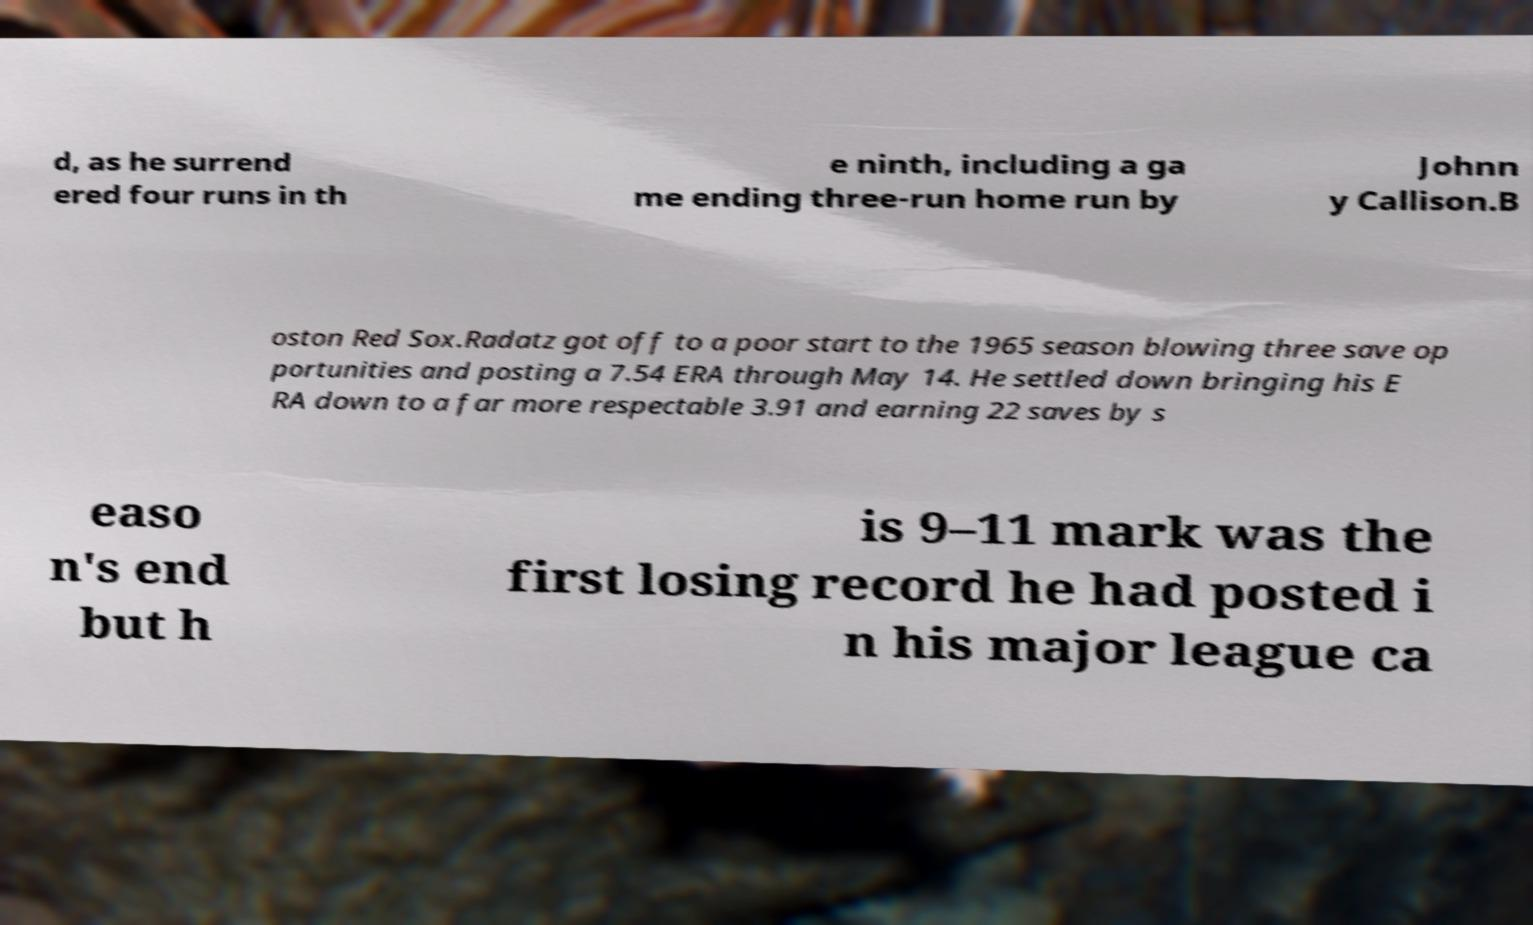Can you accurately transcribe the text from the provided image for me? d, as he surrend ered four runs in th e ninth, including a ga me ending three-run home run by Johnn y Callison.B oston Red Sox.Radatz got off to a poor start to the 1965 season blowing three save op portunities and posting a 7.54 ERA through May 14. He settled down bringing his E RA down to a far more respectable 3.91 and earning 22 saves by s easo n's end but h is 9–11 mark was the first losing record he had posted i n his major league ca 